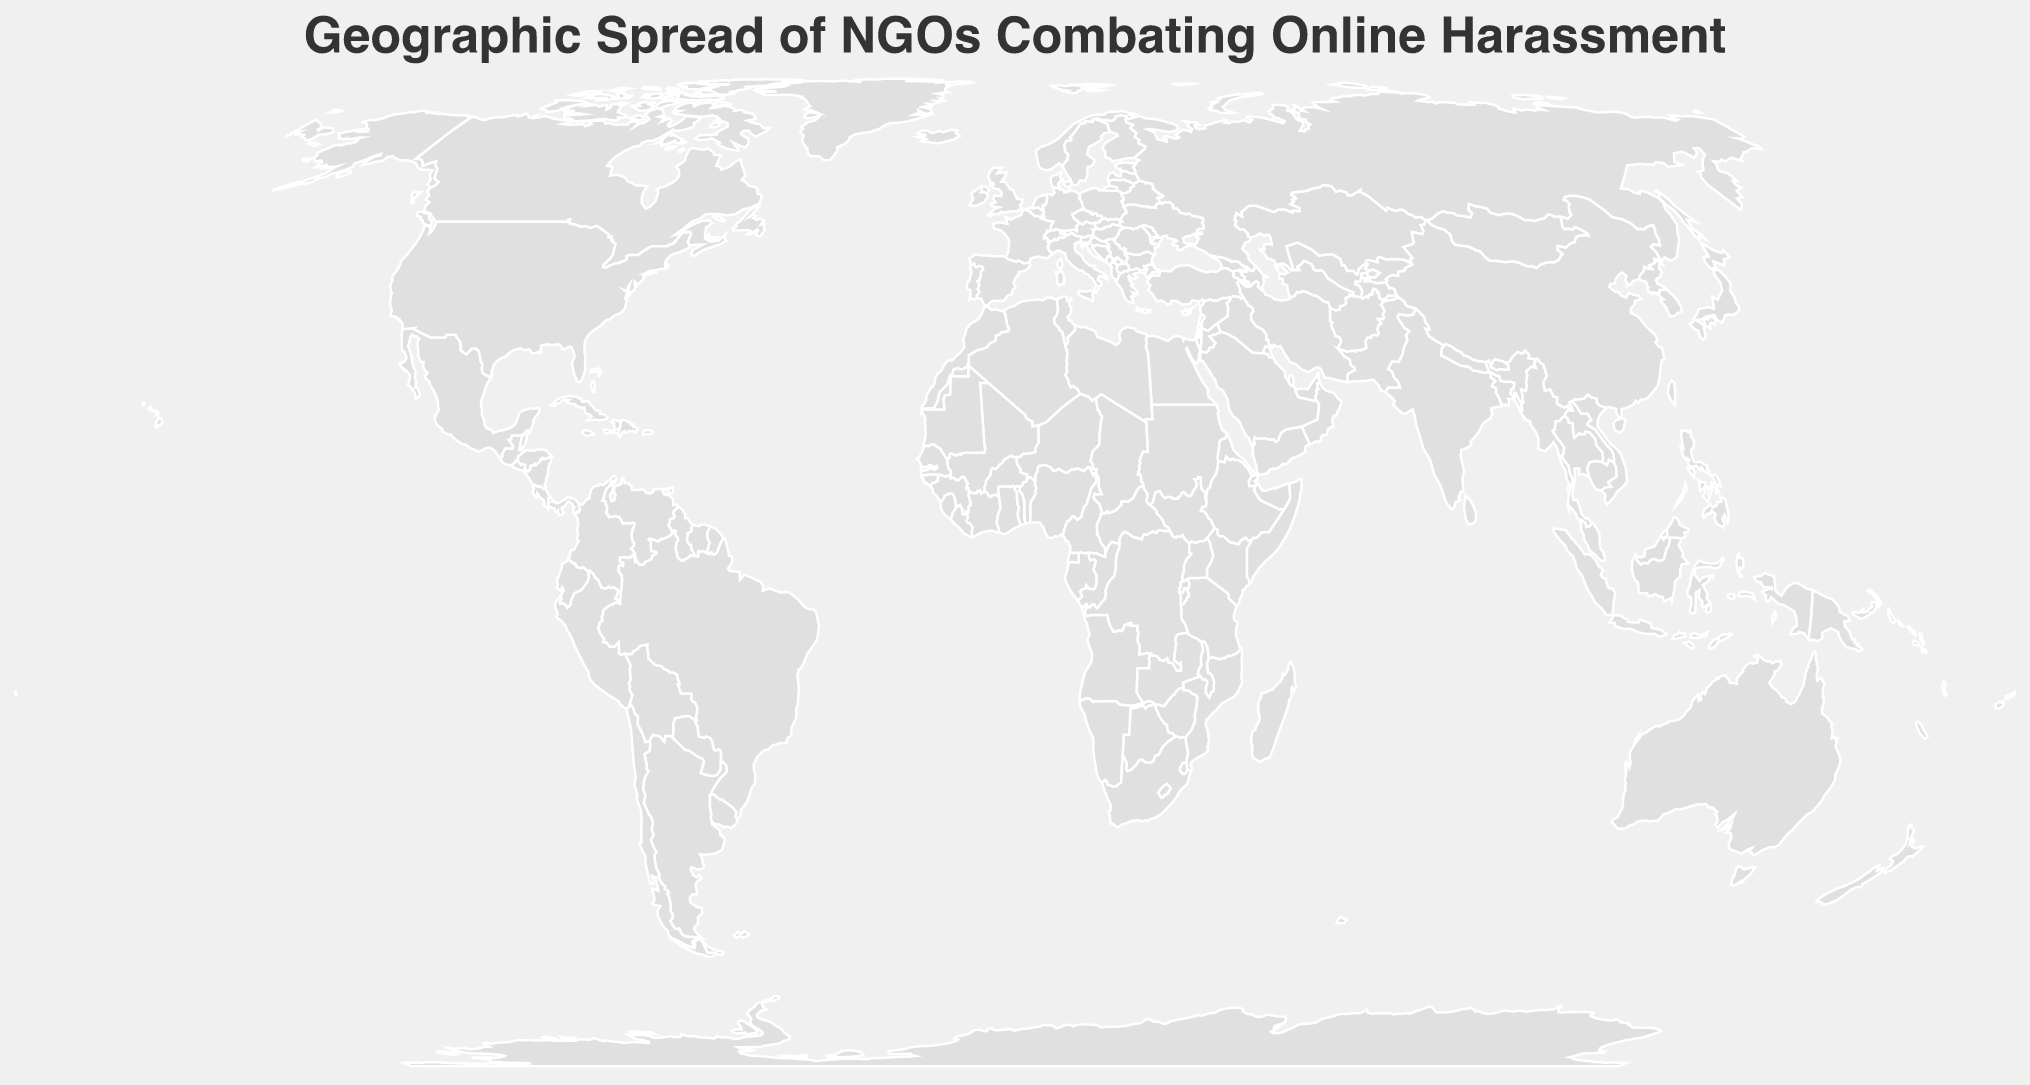Which country has the NGO with the most employees? By examining the plotted circles, the largest circle corresponds to Australia with the eSafety Commissioner having 60 employees.
Answer: Australia What is the focus area of the NGO in Canada? Looking at the tooltip information associated with the Canada point, we can see that MediaSmarts focuses on Digital Literacy.
Answer: Digital Literacy How many NGOs focused on Cyberbullying are shown on the map? By filtering the plotted points for NGOs with "Cyberbullying" as their focus area, we find three: Internet Watch Foundation in the United Kingdom, Safer Internet Association in Japan, and Digital Law Company in South Africa.
Answer: 3 Which organization was established the earliest, and in which country is it located? Referring to the tooltips and comparing the established years, Centre for Social Research in India, established in 1983, is the oldest.
Answer: Centre for Social Research, India Compare the number of employees between Germany and Japan's NGOs. Which has more? By examining the tooltips, we see that jugendschutz.net in Germany has 40 employees, while Safer Internet Association in Japan has 20 employees. Hence, Germany's NGO has more employees.
Answer: Germany Which NGOs were established in or after 2010? By checking each point's tooltip, the NGOs established in or after 2010 are: Cyber Civil Rights Initiative in the United States (2013), eSafety Commissioner in Australia (2015), Safer Internet Association in Japan (2013), and Digital Law Company in South Africa (2012).
Answer: 4 What is the total number of employees across all NGOs focused on Digital Rights? Adding the employees of SaferNet Brasil (28) and Bits of Freedom (25), we get 53.
Answer: 53 How is the geographic spread of NGOs focusing on Online Wellness and Online Safety different? Online Wellness is focused on by TOUCH Cyber Wellness in Singapore, marked in Southeast Asia, while Online Safety is the focus of eSafety Commissioner in Australia, marked in Oceania.
Answer: They are focused in Southeast Asia and Oceania respectively What is the average number of employees for organizations established between 2000 and 2010? Organizations: TOUCH Cyber Wellness (22), SaferNet Brasil (28), KICTANet (10), PantallasAmigas (12). Sum of employees = 72. Number of organizations = 4. Average = 72/4 = 18.
Answer: 18 Which NGO in Europe has the smallest number of employees, and how many do they have? Looking at the points in Europe, e-Enfance in France has the least employees with 18.
Answer: e-Enfance, 18 